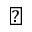Convert formula to latex. <formula><loc_0><loc_0><loc_500><loc_500>\blacktriangle</formula> 